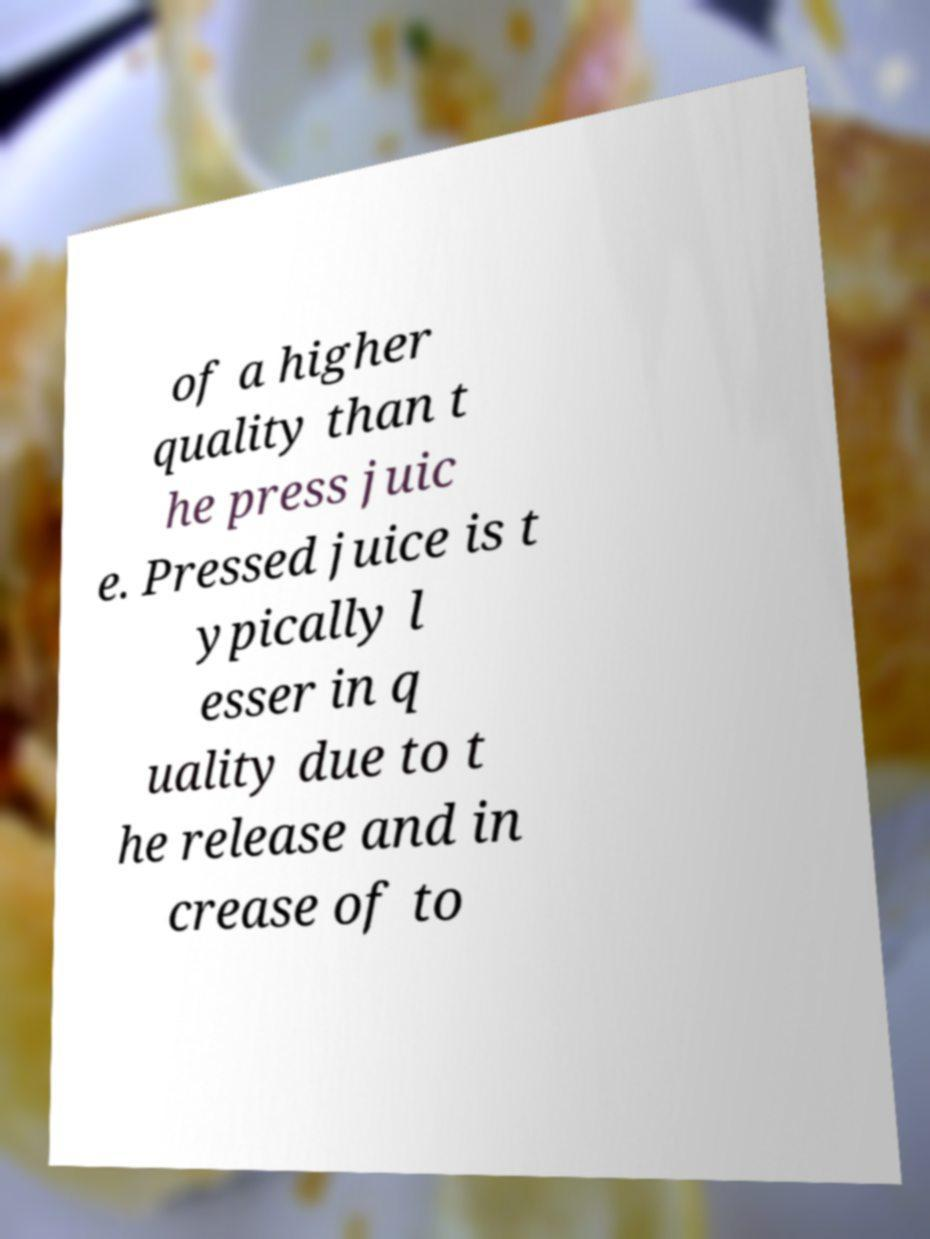There's text embedded in this image that I need extracted. Can you transcribe it verbatim? of a higher quality than t he press juic e. Pressed juice is t ypically l esser in q uality due to t he release and in crease of to 